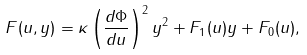<formula> <loc_0><loc_0><loc_500><loc_500>F ( u , y ) = \kappa \left ( \frac { d \Phi } { d u } \right ) ^ { 2 } y ^ { 2 } + F _ { 1 } ( u ) y + F _ { 0 } ( u ) ,</formula> 